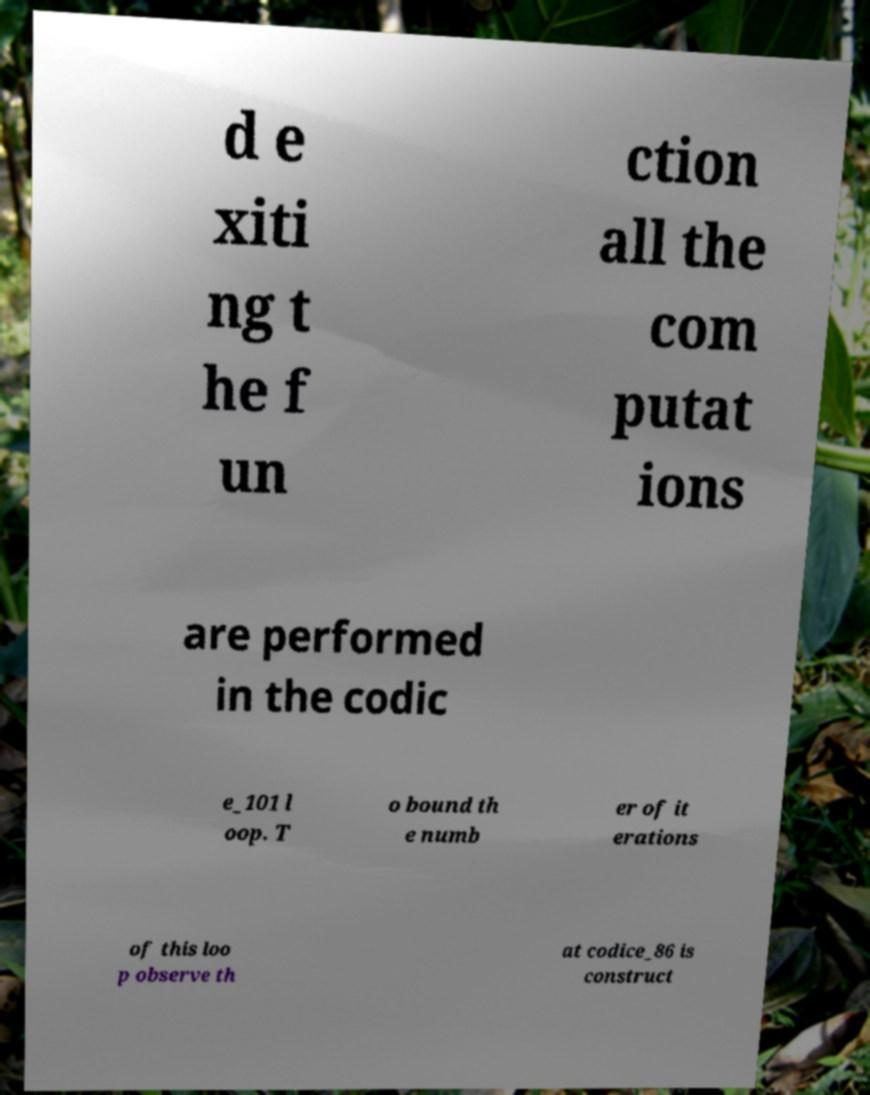I need the written content from this picture converted into text. Can you do that? d e xiti ng t he f un ction all the com putat ions are performed in the codic e_101 l oop. T o bound th e numb er of it erations of this loo p observe th at codice_86 is construct 